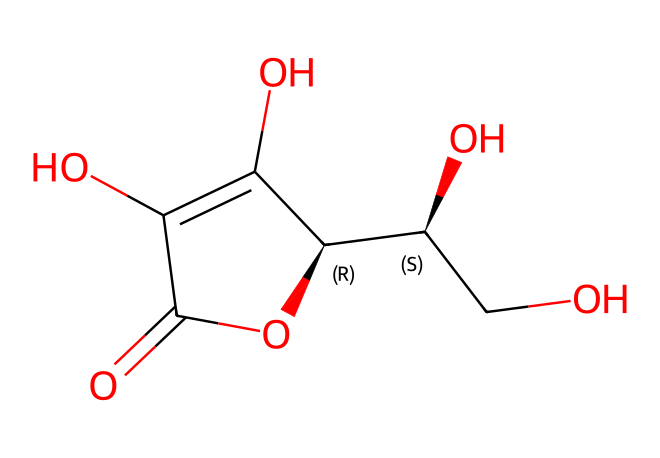What is the molecular formula of ascorbic acid? The SMILES representation can be converted to determine the molecular formula. By counting each type of atom represented, we find it consists of 6 carbons, 8 hydrogens, and 6 oxygens, giving it the molecular formula C6H8O6.
Answer: C6H8O6 How many hydroxyl (-OH) groups are present in ascorbic acid? By analyzing the structure, we can identify the presence of hydroxyl groups. In the chemical structure, there are 4 clear hydroxyl groups attached to the carbon framework.
Answer: 4 What type of functional groups are present in ascorbic acid? Analyzing the structure reveals that ascorbic acid contains hydroxyl (-OH) and carbonyl (C=O) functional groups. The hydroxyl groups contribute to its acidity, while the carbonyl group provides reactivity.
Answer: hydroxyl and carbonyl What characteristic makes ascorbic acid an acid? The presence of a proton (H+) that can be released identifies a compound as an acid. In ascorbic acid, the hydroxyl groups can release protons, contributing to its acidic nature.
Answer: proton What is the stereochemistry of the central carbon in ascorbic acid? Looking at the structure, one of the carbons is attached to four different substituents, indicating chirality. The carbon has a specific spatial arrangement, denoted by the '@' symbol in the SMILES, confirming it has stereoisomerism with specific configurations.
Answer: chiral How does the structure of ascorbic acid relate to its antioxidant properties? Ascorbic acid has multiple hydroxyl groups that can donate electrons and stabilize free radicals. The structure's arrangement allows for effective electron donation, which is central to its function as an antioxidant.
Answer: electron donation 